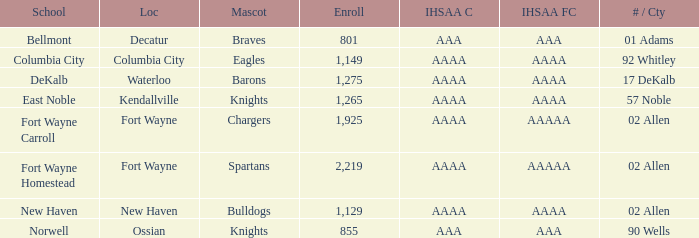What's the enrollment for Kendallville? 1265.0. 